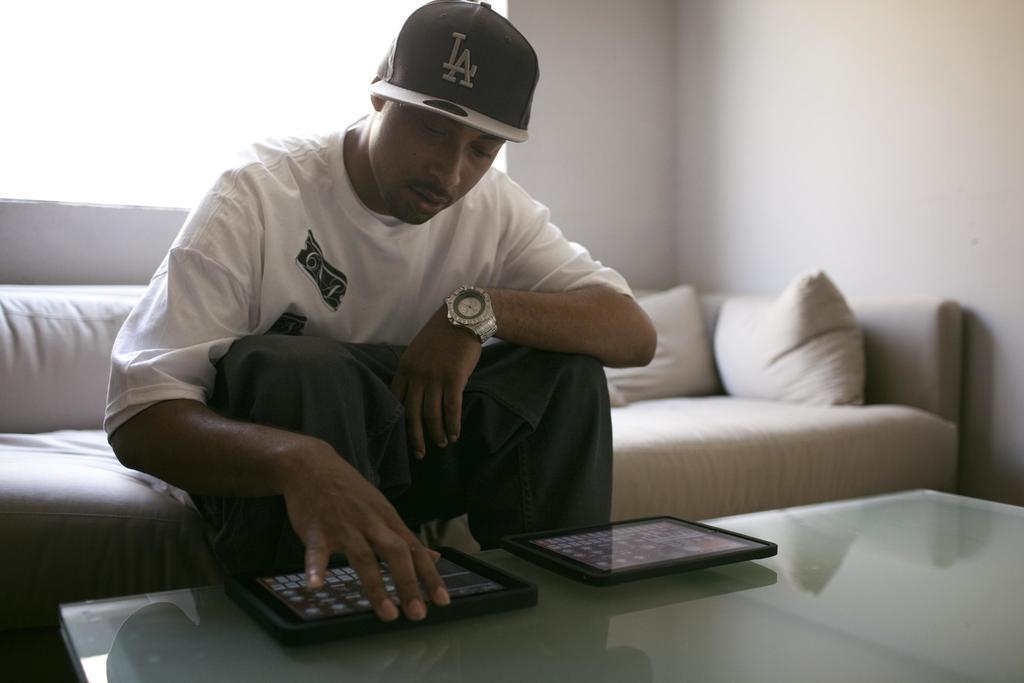Describe this image in one or two sentences. This is a picture of a man sitting on the white sofa on the sofa there are the pillows in front of the man there is a glass table on the table there is a mobile phones to the man man having a watch to his right hand and black hat and the background of the man is a white wall. 